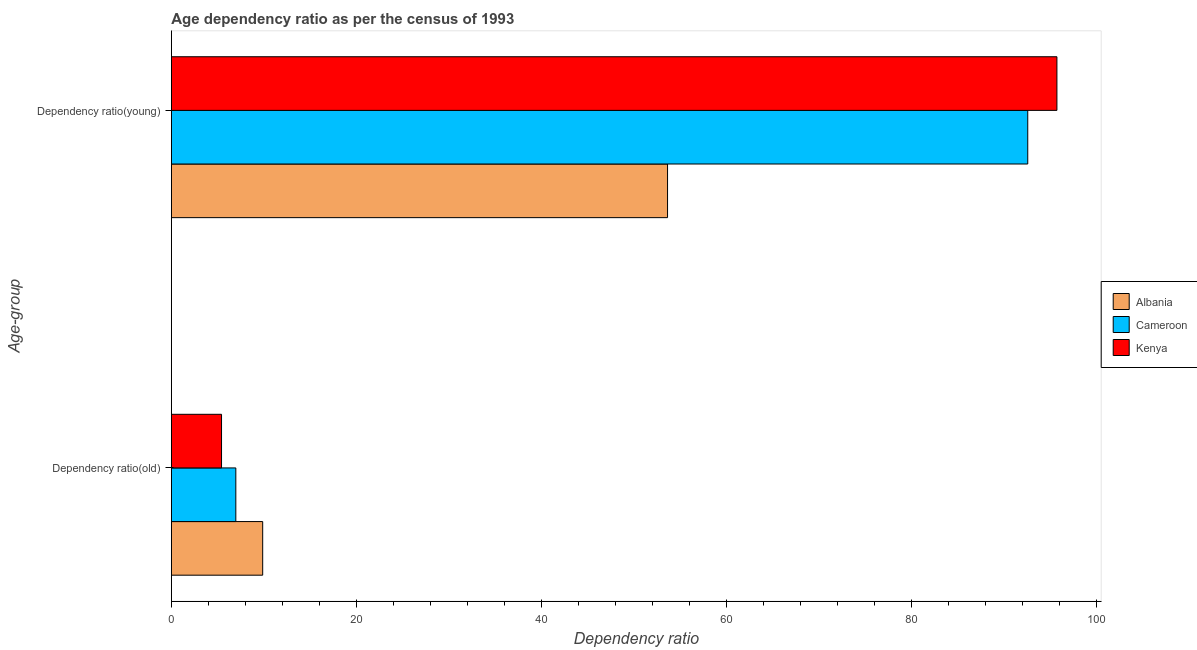How many different coloured bars are there?
Keep it short and to the point. 3. Are the number of bars on each tick of the Y-axis equal?
Your answer should be compact. Yes. What is the label of the 2nd group of bars from the top?
Provide a succinct answer. Dependency ratio(old). What is the age dependency ratio(young) in Kenya?
Provide a short and direct response. 95.77. Across all countries, what is the maximum age dependency ratio(old)?
Make the answer very short. 9.87. Across all countries, what is the minimum age dependency ratio(old)?
Offer a very short reply. 5.42. In which country was the age dependency ratio(young) maximum?
Keep it short and to the point. Kenya. In which country was the age dependency ratio(young) minimum?
Your answer should be compact. Albania. What is the total age dependency ratio(young) in the graph?
Your answer should be compact. 242.05. What is the difference between the age dependency ratio(old) in Albania and that in Cameroon?
Your answer should be very brief. 2.9. What is the difference between the age dependency ratio(old) in Kenya and the age dependency ratio(young) in Cameroon?
Provide a succinct answer. -87.19. What is the average age dependency ratio(young) per country?
Offer a terse response. 80.68. What is the difference between the age dependency ratio(young) and age dependency ratio(old) in Albania?
Keep it short and to the point. 43.79. In how many countries, is the age dependency ratio(old) greater than 32 ?
Your response must be concise. 0. What is the ratio of the age dependency ratio(old) in Kenya to that in Cameroon?
Offer a very short reply. 0.78. Is the age dependency ratio(young) in Albania less than that in Kenya?
Ensure brevity in your answer.  Yes. What does the 1st bar from the top in Dependency ratio(young) represents?
Ensure brevity in your answer.  Kenya. What does the 2nd bar from the bottom in Dependency ratio(old) represents?
Your answer should be compact. Cameroon. How many bars are there?
Your answer should be compact. 6. How many countries are there in the graph?
Offer a very short reply. 3. Does the graph contain any zero values?
Provide a succinct answer. No. Does the graph contain grids?
Your answer should be compact. No. Where does the legend appear in the graph?
Your answer should be very brief. Center right. How many legend labels are there?
Ensure brevity in your answer.  3. What is the title of the graph?
Your answer should be very brief. Age dependency ratio as per the census of 1993. Does "Macedonia" appear as one of the legend labels in the graph?
Offer a terse response. No. What is the label or title of the X-axis?
Your answer should be compact. Dependency ratio. What is the label or title of the Y-axis?
Offer a terse response. Age-group. What is the Dependency ratio in Albania in Dependency ratio(old)?
Your response must be concise. 9.87. What is the Dependency ratio in Cameroon in Dependency ratio(old)?
Make the answer very short. 6.97. What is the Dependency ratio in Kenya in Dependency ratio(old)?
Your answer should be compact. 5.42. What is the Dependency ratio of Albania in Dependency ratio(young)?
Give a very brief answer. 53.66. What is the Dependency ratio in Cameroon in Dependency ratio(young)?
Your answer should be compact. 92.62. What is the Dependency ratio of Kenya in Dependency ratio(young)?
Make the answer very short. 95.77. Across all Age-group, what is the maximum Dependency ratio in Albania?
Give a very brief answer. 53.66. Across all Age-group, what is the maximum Dependency ratio of Cameroon?
Provide a succinct answer. 92.62. Across all Age-group, what is the maximum Dependency ratio in Kenya?
Offer a terse response. 95.77. Across all Age-group, what is the minimum Dependency ratio in Albania?
Your answer should be compact. 9.87. Across all Age-group, what is the minimum Dependency ratio in Cameroon?
Your response must be concise. 6.97. Across all Age-group, what is the minimum Dependency ratio of Kenya?
Provide a succinct answer. 5.42. What is the total Dependency ratio in Albania in the graph?
Offer a very short reply. 63.54. What is the total Dependency ratio in Cameroon in the graph?
Your answer should be compact. 99.59. What is the total Dependency ratio in Kenya in the graph?
Provide a succinct answer. 101.19. What is the difference between the Dependency ratio in Albania in Dependency ratio(old) and that in Dependency ratio(young)?
Make the answer very short. -43.79. What is the difference between the Dependency ratio of Cameroon in Dependency ratio(old) and that in Dependency ratio(young)?
Offer a very short reply. -85.65. What is the difference between the Dependency ratio of Kenya in Dependency ratio(old) and that in Dependency ratio(young)?
Keep it short and to the point. -90.35. What is the difference between the Dependency ratio in Albania in Dependency ratio(old) and the Dependency ratio in Cameroon in Dependency ratio(young)?
Ensure brevity in your answer.  -82.74. What is the difference between the Dependency ratio in Albania in Dependency ratio(old) and the Dependency ratio in Kenya in Dependency ratio(young)?
Keep it short and to the point. -85.9. What is the difference between the Dependency ratio of Cameroon in Dependency ratio(old) and the Dependency ratio of Kenya in Dependency ratio(young)?
Offer a very short reply. -88.8. What is the average Dependency ratio of Albania per Age-group?
Offer a terse response. 31.77. What is the average Dependency ratio of Cameroon per Age-group?
Your answer should be compact. 49.79. What is the average Dependency ratio of Kenya per Age-group?
Ensure brevity in your answer.  50.6. What is the difference between the Dependency ratio of Albania and Dependency ratio of Cameroon in Dependency ratio(old)?
Offer a very short reply. 2.9. What is the difference between the Dependency ratio of Albania and Dependency ratio of Kenya in Dependency ratio(old)?
Give a very brief answer. 4.45. What is the difference between the Dependency ratio of Cameroon and Dependency ratio of Kenya in Dependency ratio(old)?
Offer a terse response. 1.55. What is the difference between the Dependency ratio of Albania and Dependency ratio of Cameroon in Dependency ratio(young)?
Offer a terse response. -38.95. What is the difference between the Dependency ratio of Albania and Dependency ratio of Kenya in Dependency ratio(young)?
Offer a very short reply. -42.11. What is the difference between the Dependency ratio in Cameroon and Dependency ratio in Kenya in Dependency ratio(young)?
Keep it short and to the point. -3.15. What is the ratio of the Dependency ratio of Albania in Dependency ratio(old) to that in Dependency ratio(young)?
Keep it short and to the point. 0.18. What is the ratio of the Dependency ratio of Cameroon in Dependency ratio(old) to that in Dependency ratio(young)?
Make the answer very short. 0.08. What is the ratio of the Dependency ratio in Kenya in Dependency ratio(old) to that in Dependency ratio(young)?
Your answer should be compact. 0.06. What is the difference between the highest and the second highest Dependency ratio in Albania?
Your response must be concise. 43.79. What is the difference between the highest and the second highest Dependency ratio in Cameroon?
Offer a terse response. 85.65. What is the difference between the highest and the second highest Dependency ratio of Kenya?
Keep it short and to the point. 90.35. What is the difference between the highest and the lowest Dependency ratio in Albania?
Offer a terse response. 43.79. What is the difference between the highest and the lowest Dependency ratio of Cameroon?
Your answer should be compact. 85.65. What is the difference between the highest and the lowest Dependency ratio of Kenya?
Keep it short and to the point. 90.35. 